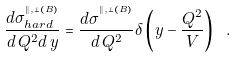Convert formula to latex. <formula><loc_0><loc_0><loc_500><loc_500>\frac { d \sigma _ { h a r d } ^ { ^ { \| , \bot ( B ) } } } { d \, Q ^ { 2 } d \, y } = \frac { d \sigma ^ { ^ { \| , \bot ( B ) } } } { d \, Q ^ { 2 } } \delta \left ( y - \frac { Q ^ { 2 } } { V } \right ) \ .</formula> 